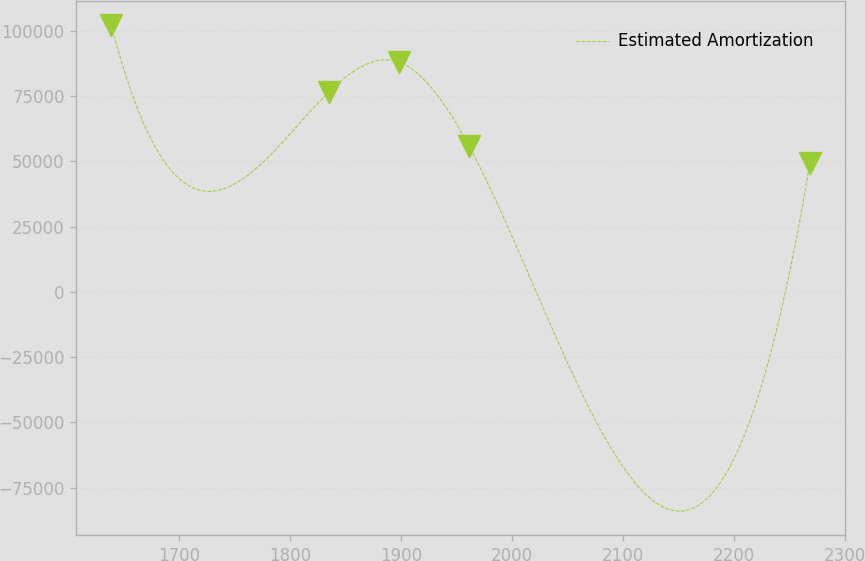Convert chart. <chart><loc_0><loc_0><loc_500><loc_500><line_chart><ecel><fcel>Estimated Amortization<nl><fcel>1638.96<fcel>102244<nl><fcel>1835.33<fcel>76716.4<nl><fcel>1898.3<fcel>88064.7<nl><fcel>1961.27<fcel>55963.2<nl><fcel>2268.62<fcel>49501.7<nl></chart> 